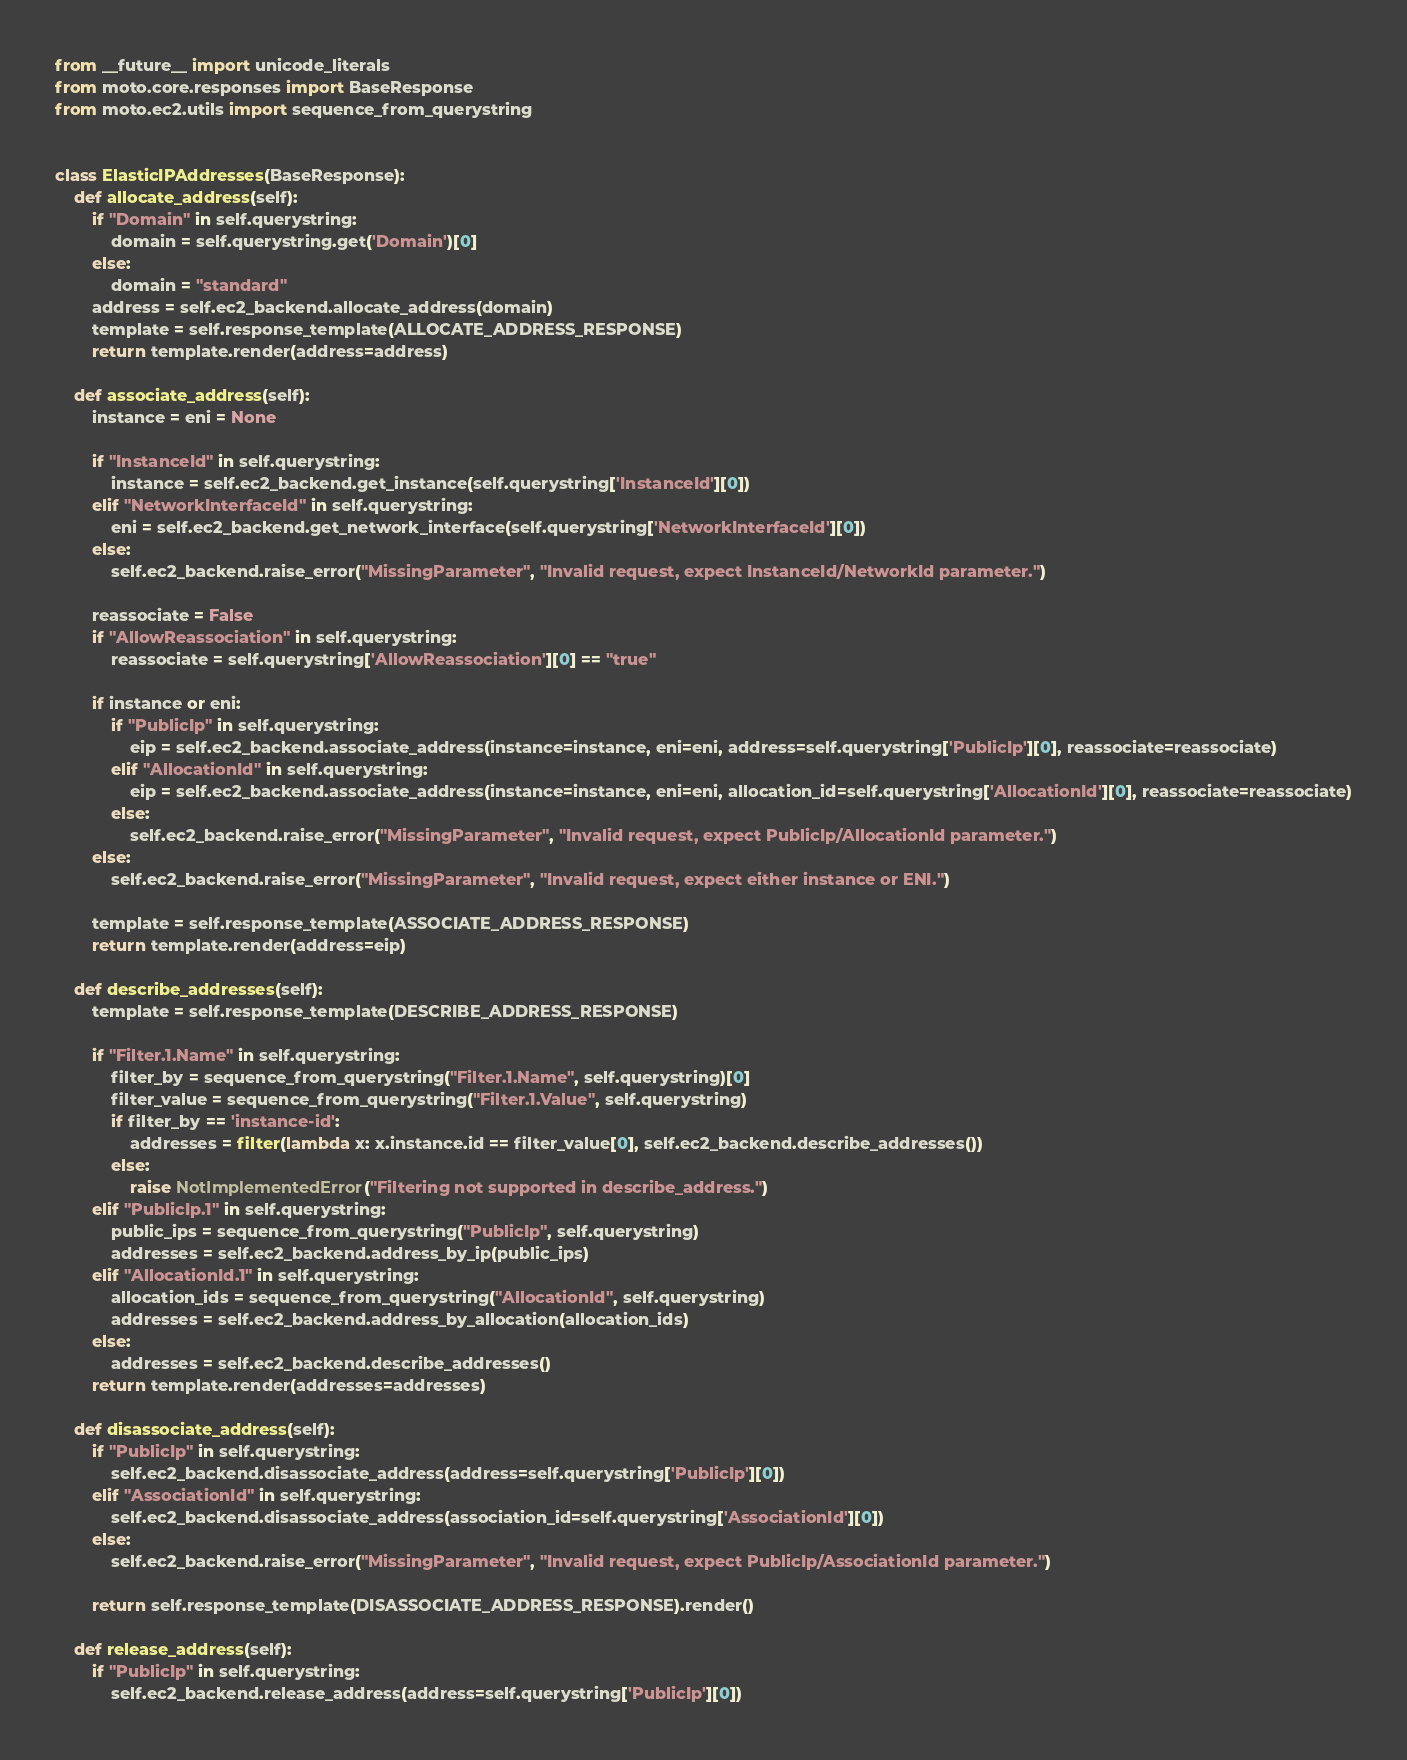Convert code to text. <code><loc_0><loc_0><loc_500><loc_500><_Python_>from __future__ import unicode_literals
from moto.core.responses import BaseResponse
from moto.ec2.utils import sequence_from_querystring


class ElasticIPAddresses(BaseResponse):
    def allocate_address(self):
        if "Domain" in self.querystring:
            domain = self.querystring.get('Domain')[0]
        else:
            domain = "standard"
        address = self.ec2_backend.allocate_address(domain)
        template = self.response_template(ALLOCATE_ADDRESS_RESPONSE)
        return template.render(address=address)

    def associate_address(self):
        instance = eni = None

        if "InstanceId" in self.querystring:
            instance = self.ec2_backend.get_instance(self.querystring['InstanceId'][0])
        elif "NetworkInterfaceId" in self.querystring:
            eni = self.ec2_backend.get_network_interface(self.querystring['NetworkInterfaceId'][0])
        else:
            self.ec2_backend.raise_error("MissingParameter", "Invalid request, expect InstanceId/NetworkId parameter.")

        reassociate = False
        if "AllowReassociation" in self.querystring:
            reassociate = self.querystring['AllowReassociation'][0] == "true"

        if instance or eni:
            if "PublicIp" in self.querystring:
                eip = self.ec2_backend.associate_address(instance=instance, eni=eni, address=self.querystring['PublicIp'][0], reassociate=reassociate)
            elif "AllocationId" in self.querystring:
                eip = self.ec2_backend.associate_address(instance=instance, eni=eni, allocation_id=self.querystring['AllocationId'][0], reassociate=reassociate)
            else:
                self.ec2_backend.raise_error("MissingParameter", "Invalid request, expect PublicIp/AllocationId parameter.")
        else:
            self.ec2_backend.raise_error("MissingParameter", "Invalid request, expect either instance or ENI.")

        template = self.response_template(ASSOCIATE_ADDRESS_RESPONSE)
        return template.render(address=eip)

    def describe_addresses(self):
        template = self.response_template(DESCRIBE_ADDRESS_RESPONSE)

        if "Filter.1.Name" in self.querystring:
            filter_by = sequence_from_querystring("Filter.1.Name", self.querystring)[0]
            filter_value = sequence_from_querystring("Filter.1.Value", self.querystring)
            if filter_by == 'instance-id':
                addresses = filter(lambda x: x.instance.id == filter_value[0], self.ec2_backend.describe_addresses())
            else:
                raise NotImplementedError("Filtering not supported in describe_address.")
        elif "PublicIp.1" in self.querystring:
            public_ips = sequence_from_querystring("PublicIp", self.querystring)
            addresses = self.ec2_backend.address_by_ip(public_ips)
        elif "AllocationId.1" in self.querystring:
            allocation_ids = sequence_from_querystring("AllocationId", self.querystring)
            addresses = self.ec2_backend.address_by_allocation(allocation_ids)
        else:
            addresses = self.ec2_backend.describe_addresses()
        return template.render(addresses=addresses)

    def disassociate_address(self):
        if "PublicIp" in self.querystring:
            self.ec2_backend.disassociate_address(address=self.querystring['PublicIp'][0])
        elif "AssociationId" in self.querystring:
            self.ec2_backend.disassociate_address(association_id=self.querystring['AssociationId'][0])
        else:
            self.ec2_backend.raise_error("MissingParameter", "Invalid request, expect PublicIp/AssociationId parameter.")

        return self.response_template(DISASSOCIATE_ADDRESS_RESPONSE).render()

    def release_address(self):
        if "PublicIp" in self.querystring:
            self.ec2_backend.release_address(address=self.querystring['PublicIp'][0])</code> 